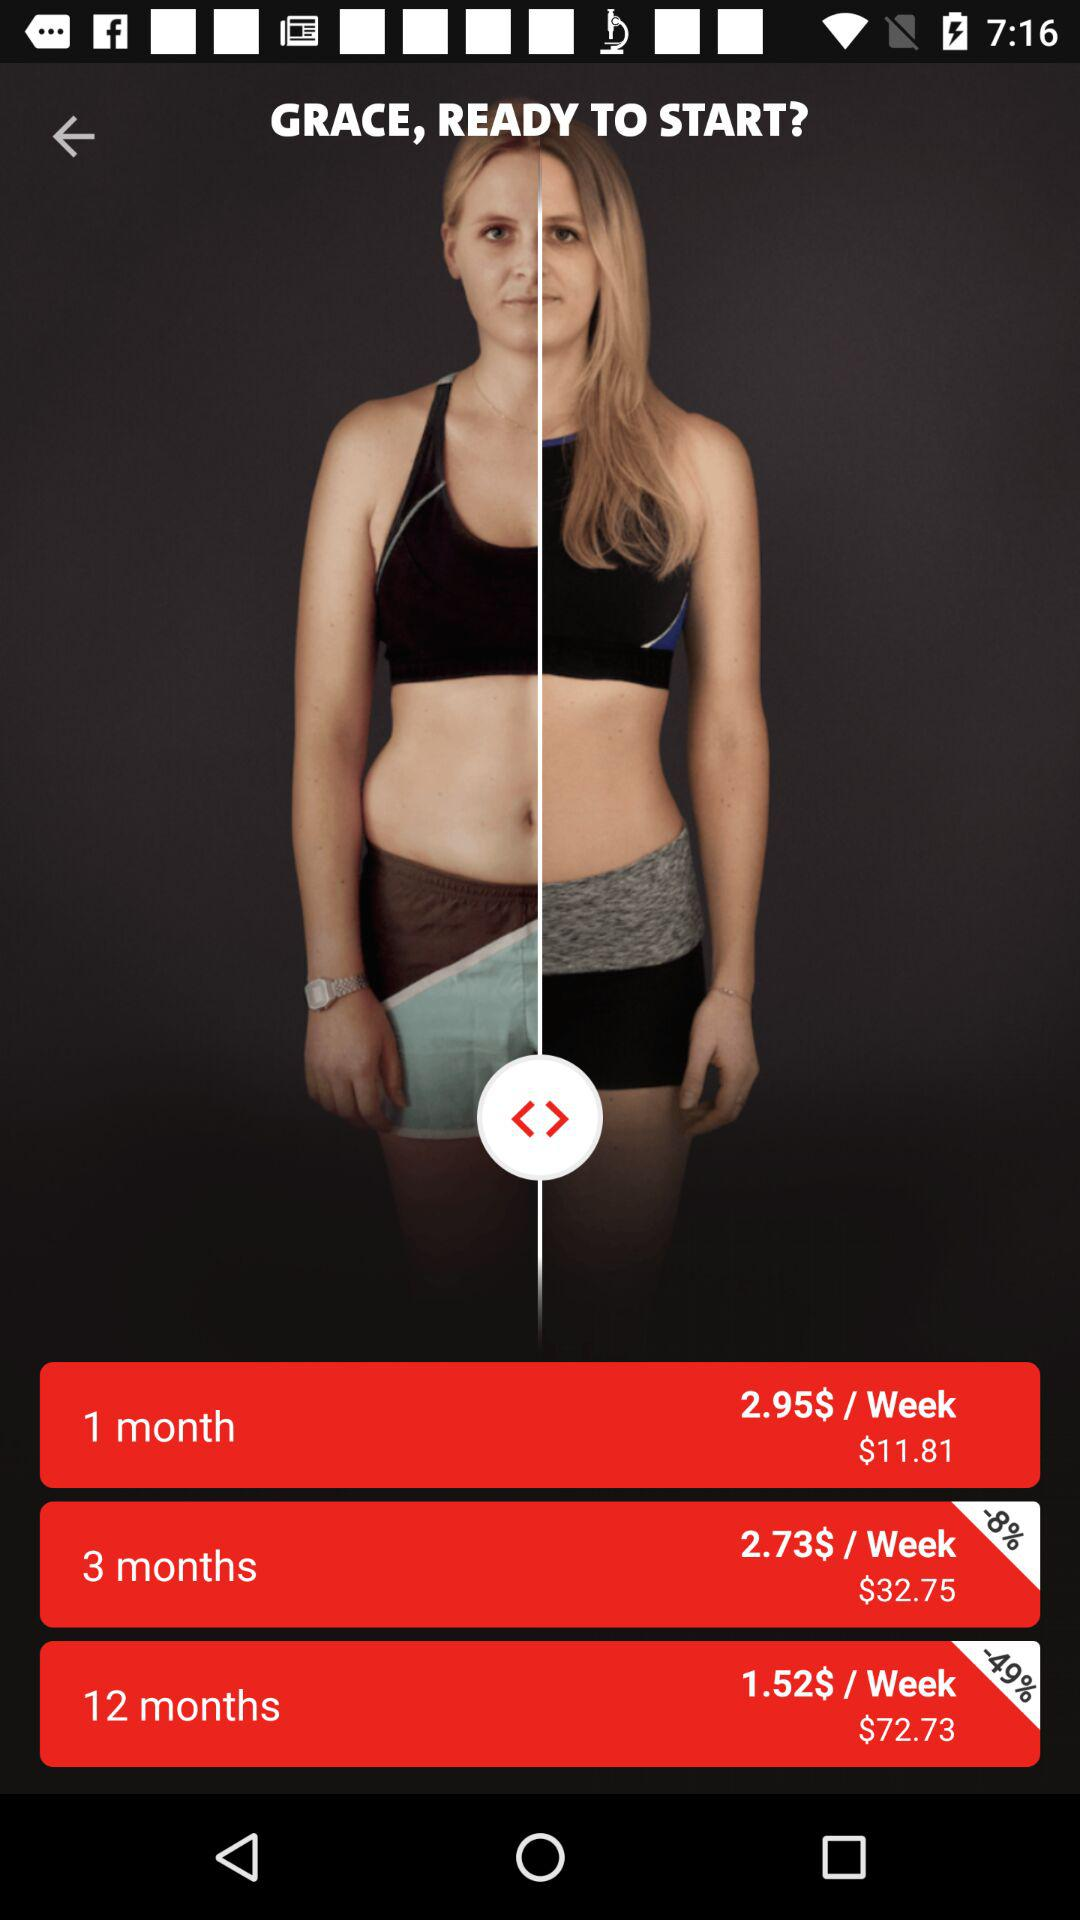What is the price per week for 1 month? The price is $2.95. 